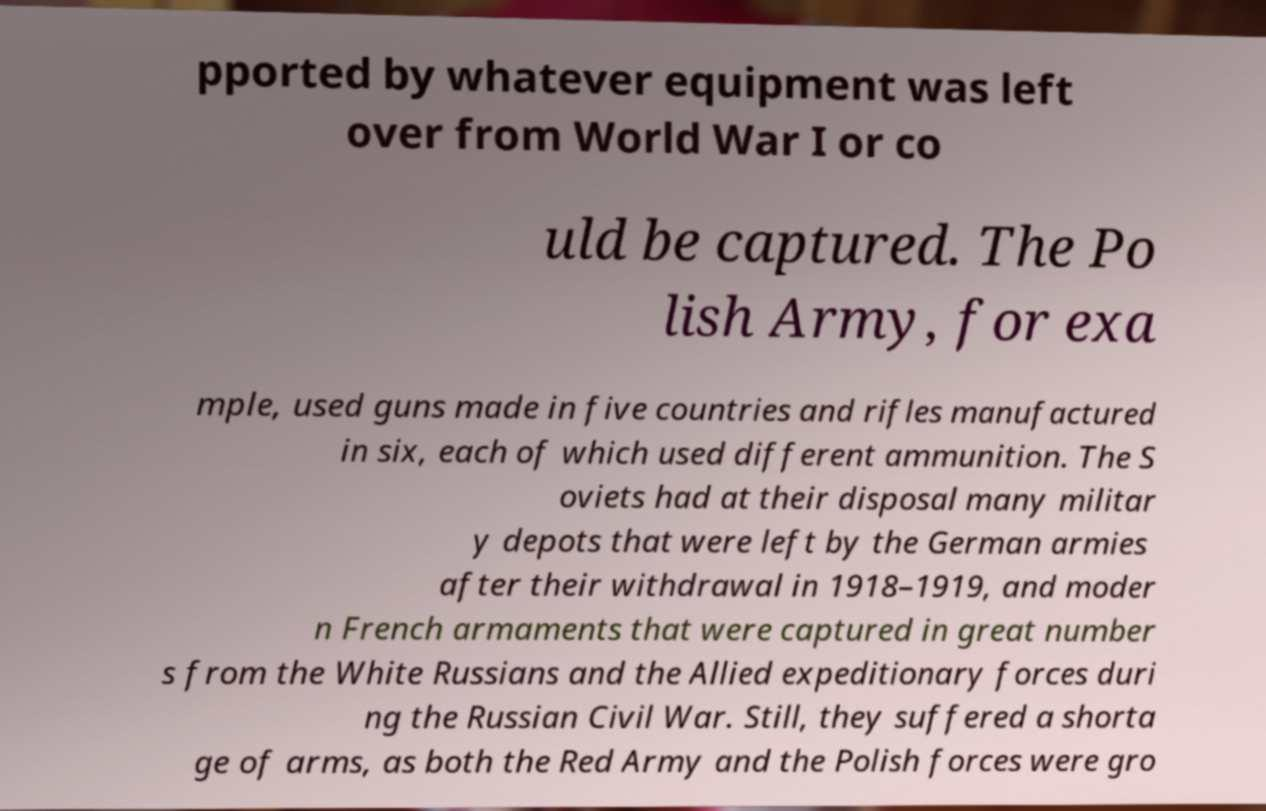Can you accurately transcribe the text from the provided image for me? pported by whatever equipment was left over from World War I or co uld be captured. The Po lish Army, for exa mple, used guns made in five countries and rifles manufactured in six, each of which used different ammunition. The S oviets had at their disposal many militar y depots that were left by the German armies after their withdrawal in 1918–1919, and moder n French armaments that were captured in great number s from the White Russians and the Allied expeditionary forces duri ng the Russian Civil War. Still, they suffered a shorta ge of arms, as both the Red Army and the Polish forces were gro 